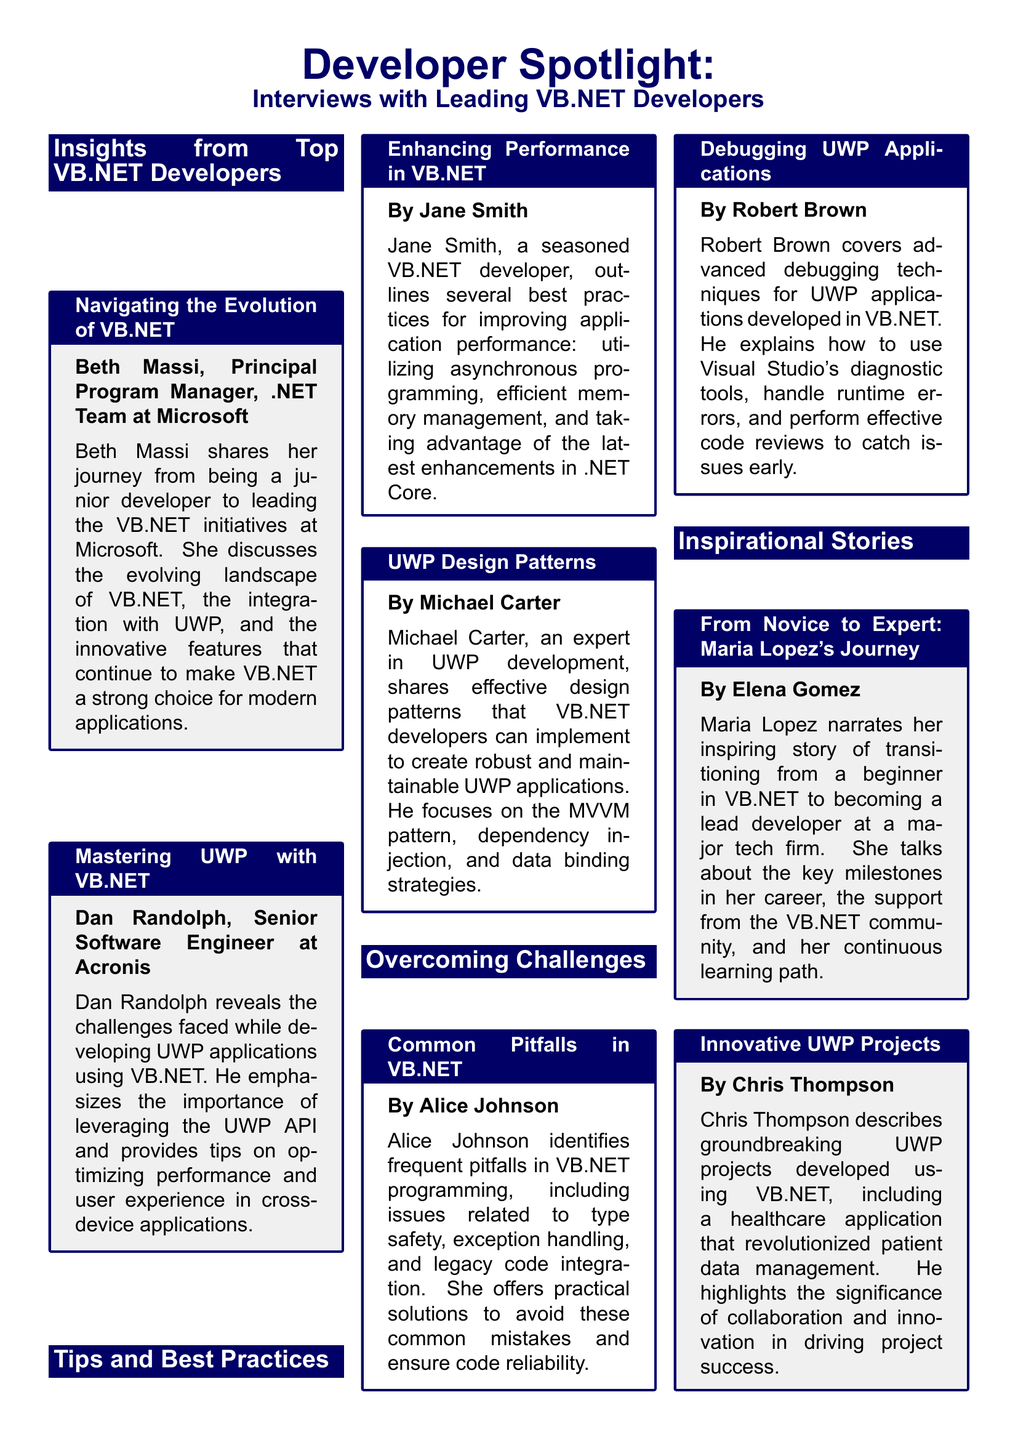What is the title of the first interview featured? The title of the first interview is "Navigating the Evolution of VB.NET" as listed in the insights section.
Answer: "Navigating the Evolution of VB.NET" Who conducted the interview about mastering UWP? The interview about mastering UWP was conducted by Dan Randolph, a Senior Software Engineer at Acronis.
Answer: Dan Randolph Which design pattern does Michael Carter focus on in his tip? Michael Carter focuses on the MVVM pattern in his tips for UWP design patterns.
Answer: MVVM pattern What is the common pitfall identified by Alice Johnson? Alice Johnson identifies issues related to type safety as a common pitfall in VB.NET programming.
Answer: Type safety How does Maria Lopez describe her journey in her inspirational story? Maria Lopez describes her journey as transitioning from a beginner in VB.NET to becoming a lead developer at a major tech firm.
Answer: From novice to expert What is the color of the title boxes used in the document? The color of the title boxes used in the document is dark blue, as defined in the document's styling.
Answer: Dark blue Who should attend the Microsoft .NET Conference? Developers interested in the latest VB.NET and UWP advancements should attend the Microsoft .NET Conference.
Answer: Developers What type of application did Chris Thompson discuss in his story? Chris Thompson discussed a healthcare application that revolutionized patient data management.
Answer: Healthcare application 